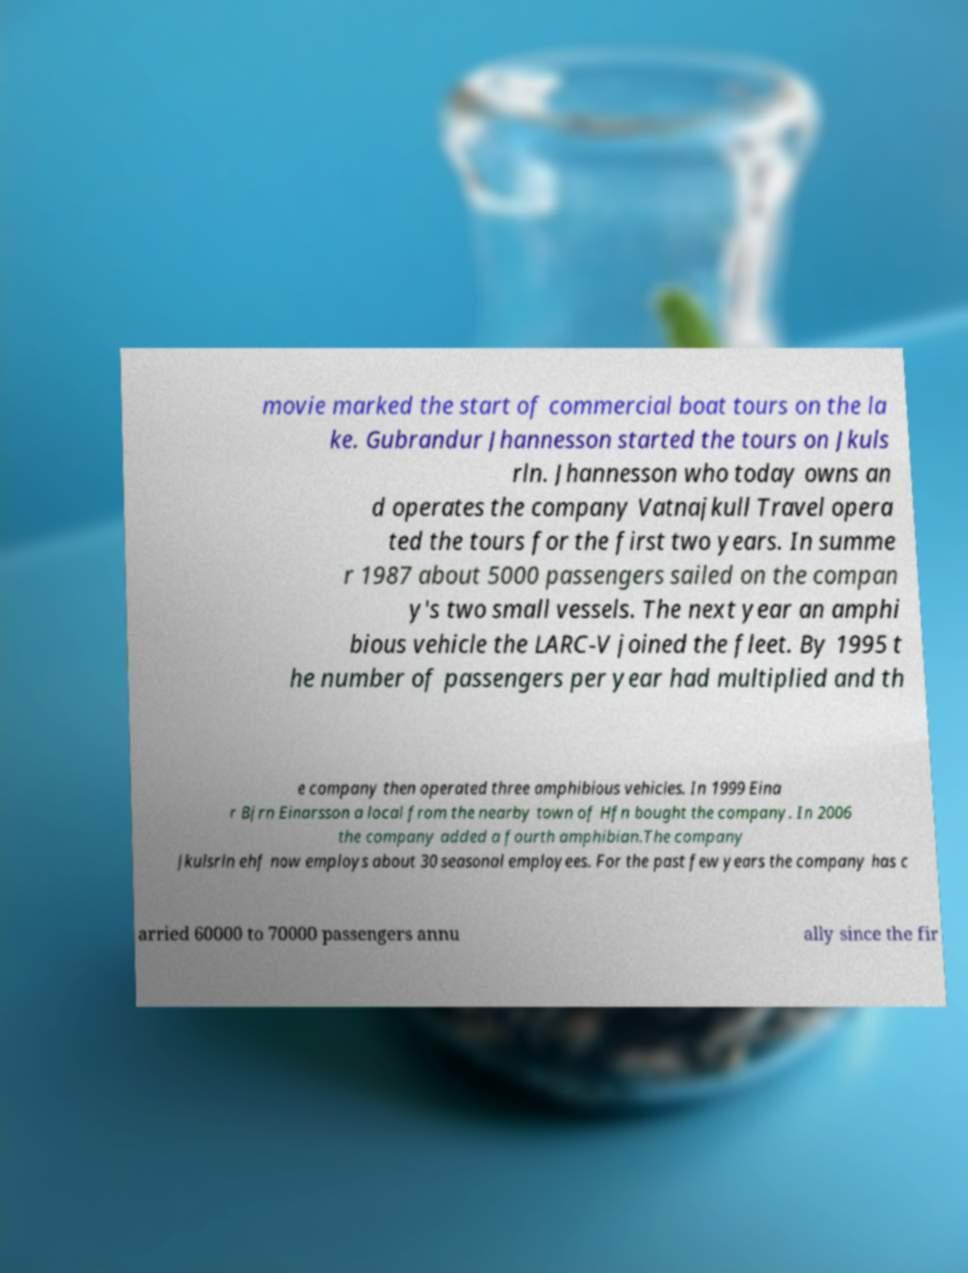Please read and relay the text visible in this image. What does it say? movie marked the start of commercial boat tours on the la ke. Gubrandur Jhannesson started the tours on Jkuls rln. Jhannesson who today owns an d operates the company Vatnajkull Travel opera ted the tours for the first two years. In summe r 1987 about 5000 passengers sailed on the compan y's two small vessels. The next year an amphi bious vehicle the LARC-V joined the fleet. By 1995 t he number of passengers per year had multiplied and th e company then operated three amphibious vehicles. In 1999 Eina r Bjrn Einarsson a local from the nearby town of Hfn bought the company. In 2006 the company added a fourth amphibian.The company Jkulsrln ehf now employs about 30 seasonal employees. For the past few years the company has c arried 60000 to 70000 passengers annu ally since the fir 